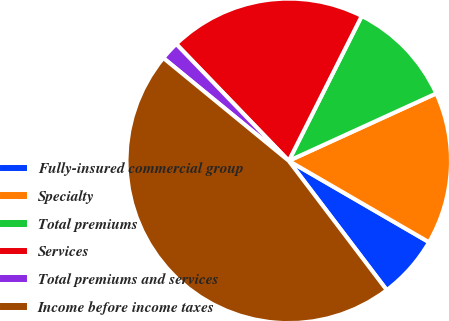Convert chart. <chart><loc_0><loc_0><loc_500><loc_500><pie_chart><fcel>Fully-insured commercial group<fcel>Specialty<fcel>Total premiums<fcel>Services<fcel>Total premiums and services<fcel>Income before income taxes<nl><fcel>6.31%<fcel>15.19%<fcel>10.75%<fcel>19.63%<fcel>1.87%<fcel>46.26%<nl></chart> 